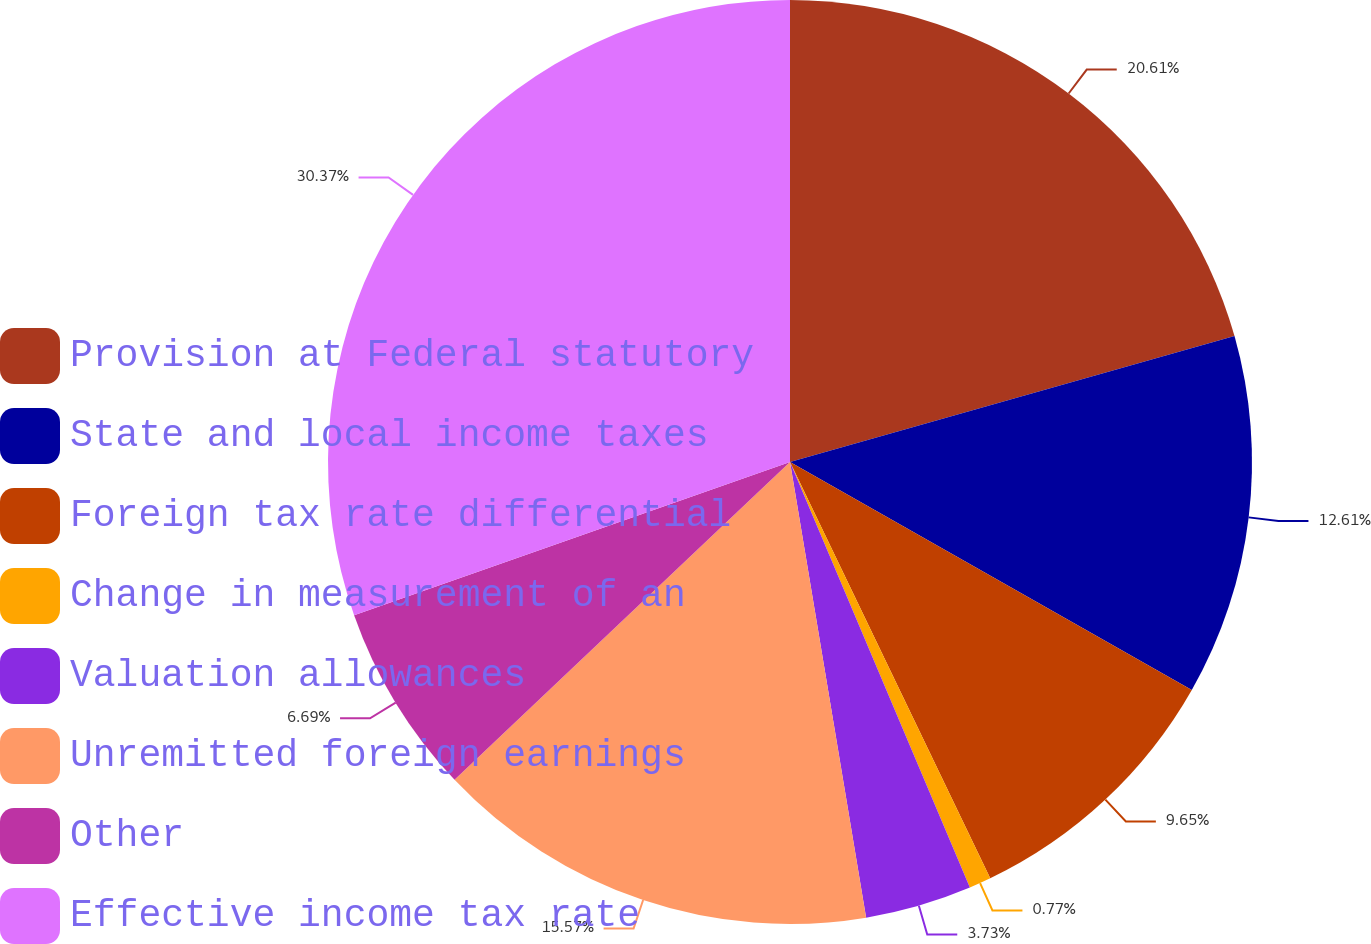Convert chart. <chart><loc_0><loc_0><loc_500><loc_500><pie_chart><fcel>Provision at Federal statutory<fcel>State and local income taxes<fcel>Foreign tax rate differential<fcel>Change in measurement of an<fcel>Valuation allowances<fcel>Unremitted foreign earnings<fcel>Other<fcel>Effective income tax rate<nl><fcel>20.61%<fcel>12.61%<fcel>9.65%<fcel>0.77%<fcel>3.73%<fcel>15.57%<fcel>6.69%<fcel>30.38%<nl></chart> 